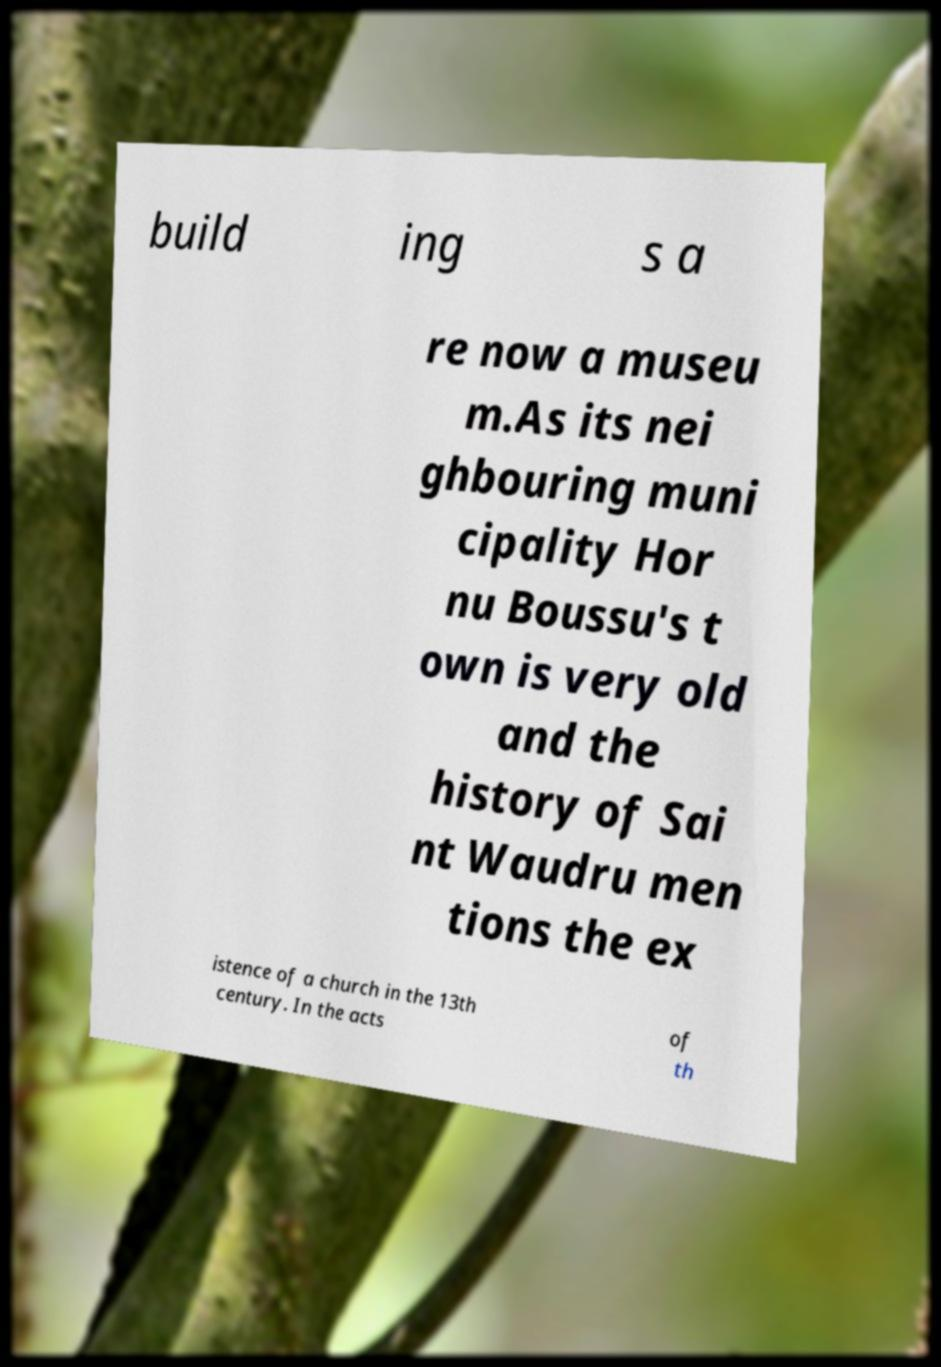Could you assist in decoding the text presented in this image and type it out clearly? build ing s a re now a museu m.As its nei ghbouring muni cipality Hor nu Boussu's t own is very old and the history of Sai nt Waudru men tions the ex istence of a church in the 13th century. In the acts of th 